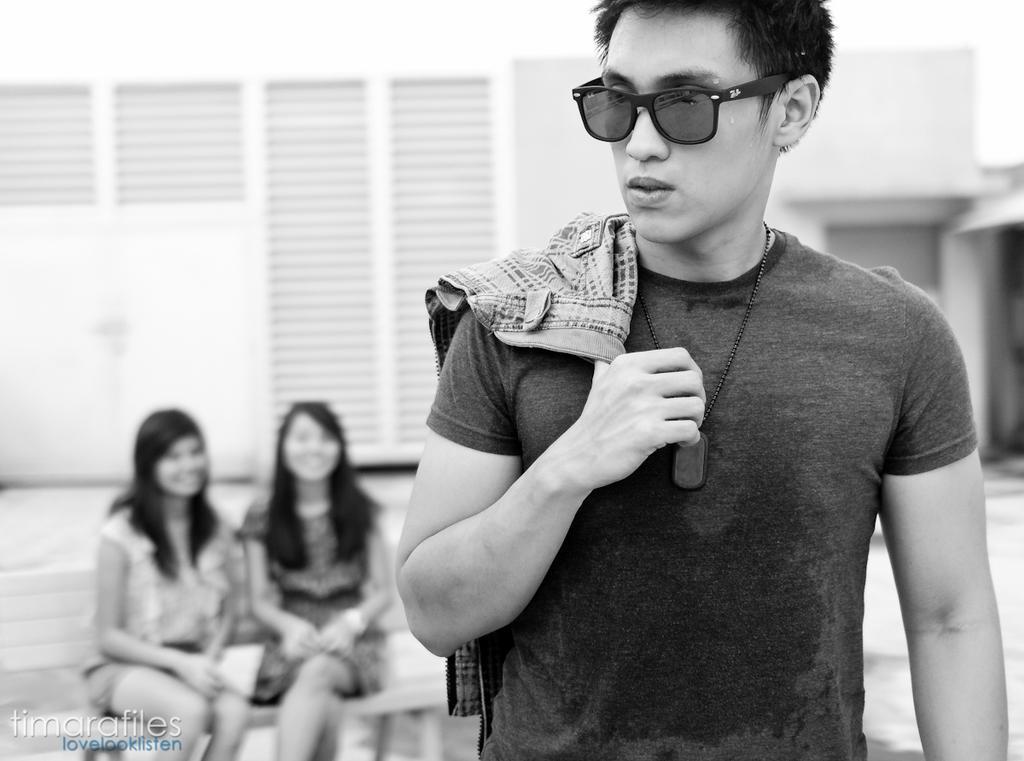Describe this image in one or two sentences. In the bottom left, there is a watermark. On the right side, there is a person in a t-shirt, placing a cloth on his shoulder and holding with one hand and standing. In the background, there are two women smiling and sitting on a bench and there is a building. 